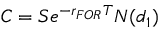Convert formula to latex. <formula><loc_0><loc_0><loc_500><loc_500>C = S e ^ { - r _ { F O R } T } N ( d _ { 1 } )</formula> 